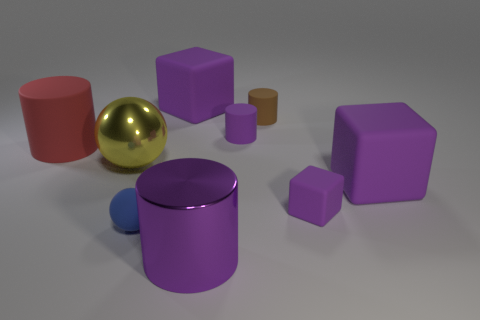Subtract all purple cubes. How many were subtracted if there are1purple cubes left? 2 Subtract all tiny blocks. How many blocks are left? 2 Subtract all gray cubes. How many purple cylinders are left? 2 Subtract all brown cylinders. How many cylinders are left? 3 Subtract all cubes. How many objects are left? 6 Subtract 1 cylinders. How many cylinders are left? 3 Add 2 purple blocks. How many purple blocks are left? 5 Add 9 brown objects. How many brown objects exist? 10 Subtract 0 brown blocks. How many objects are left? 9 Subtract all yellow balls. Subtract all gray cubes. How many balls are left? 1 